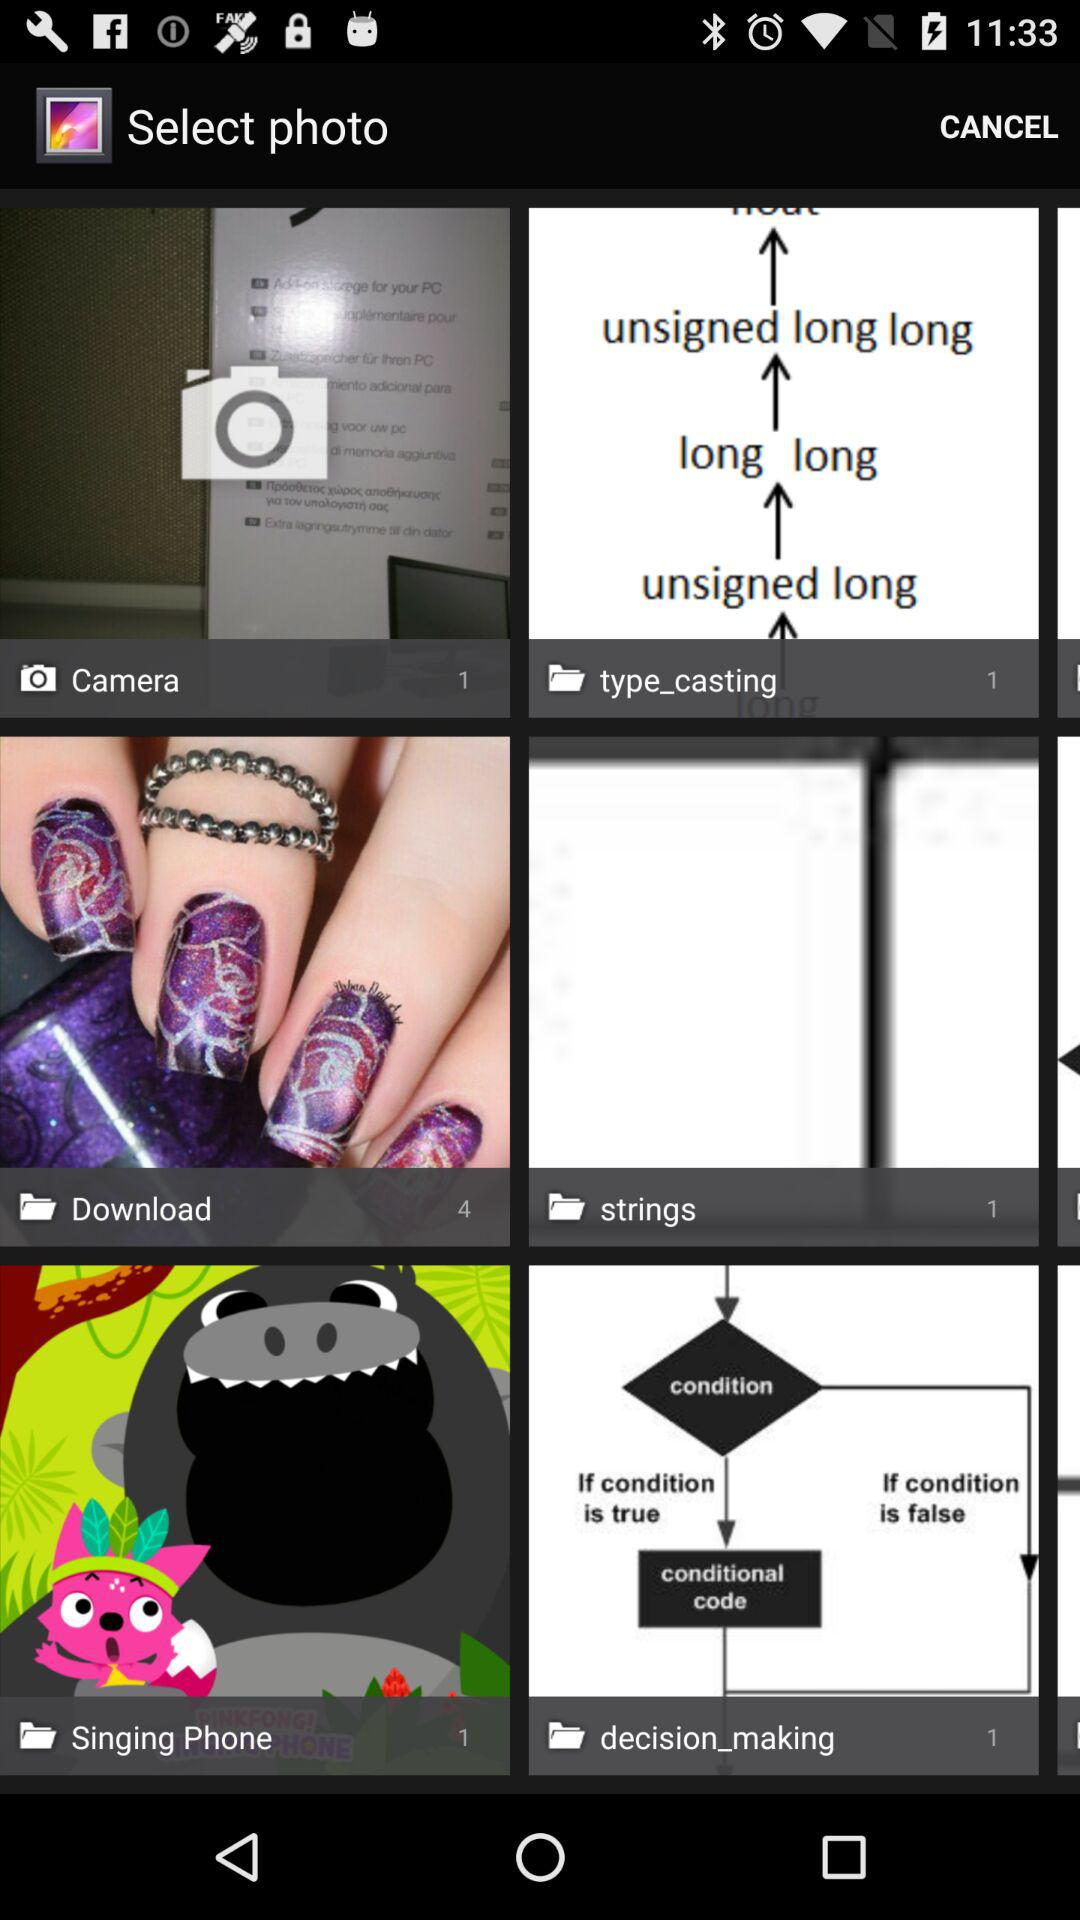How many images are there in download? There are 4 images in download. 